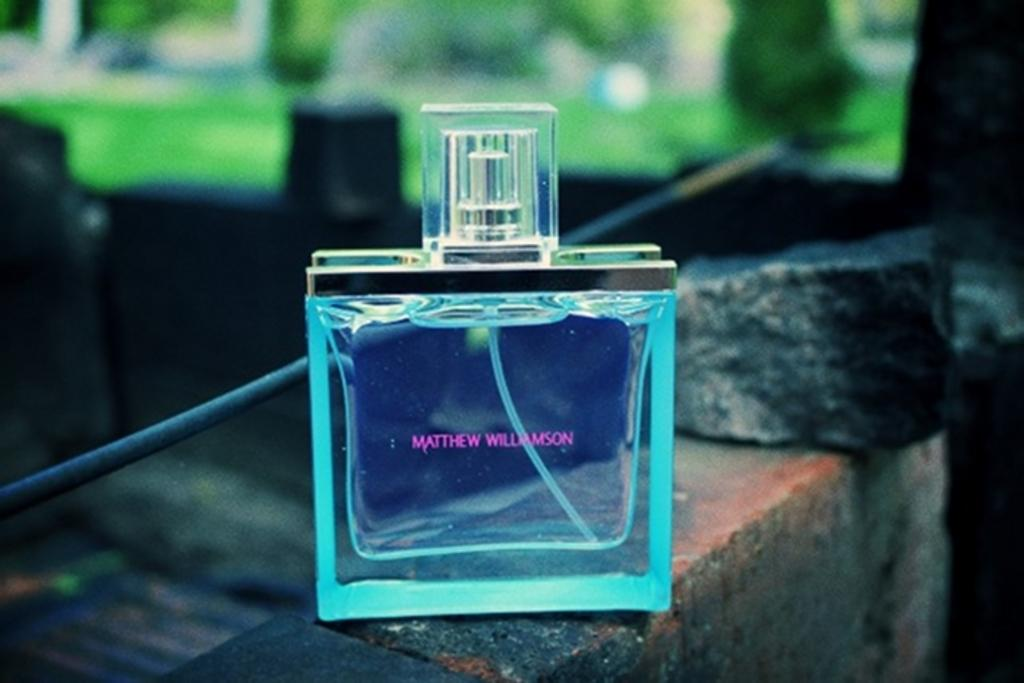<image>
Render a clear and concise summary of the photo. On top of a brick wall there is a square, aqua bottle of Mathew Williamson cologne. 